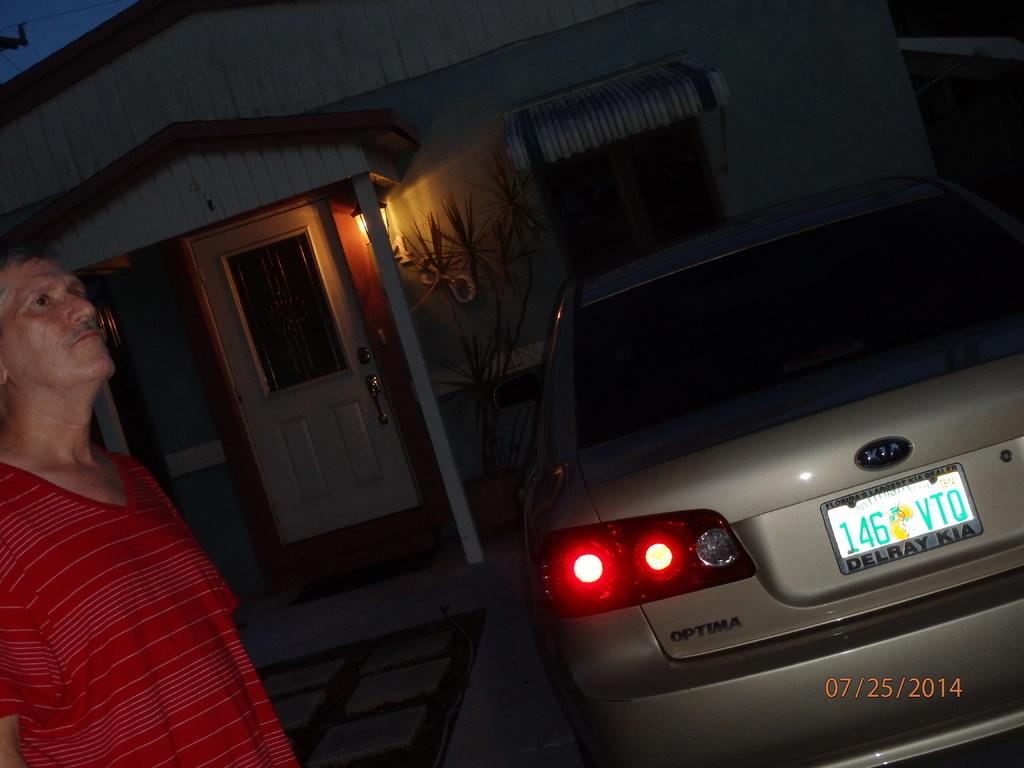<image>
Give a short and clear explanation of the subsequent image. A man in a red shirt is standing behind a silver Kia Optima and the license plate cover says Delray Kia. 